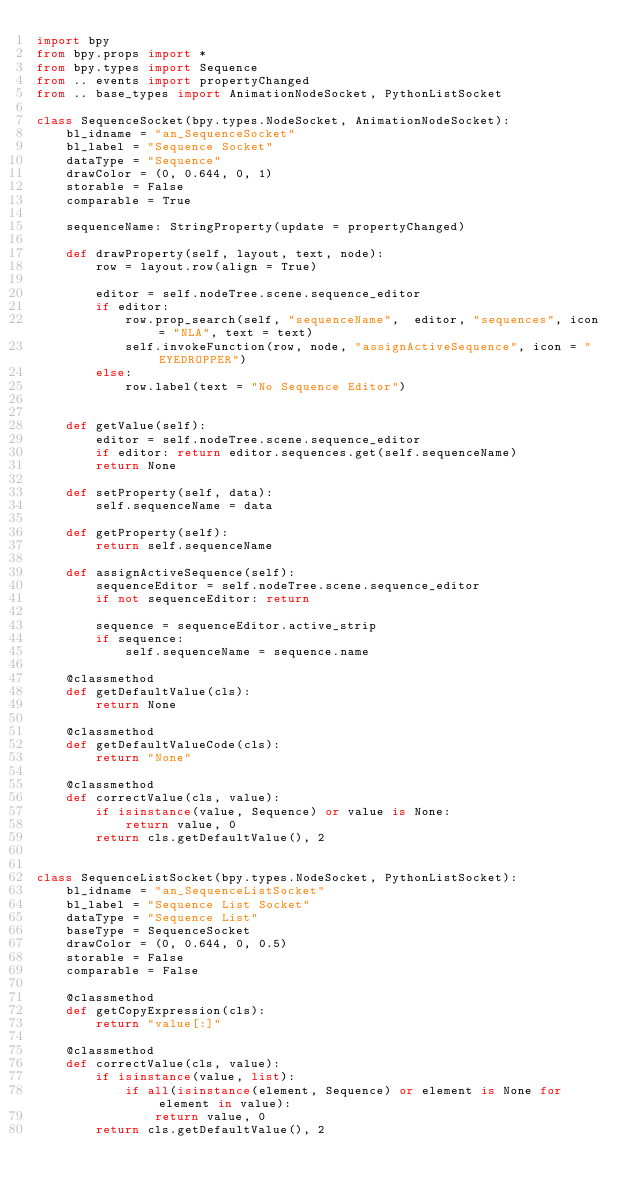<code> <loc_0><loc_0><loc_500><loc_500><_Python_>import bpy
from bpy.props import *
from bpy.types import Sequence
from .. events import propertyChanged
from .. base_types import AnimationNodeSocket, PythonListSocket

class SequenceSocket(bpy.types.NodeSocket, AnimationNodeSocket):
    bl_idname = "an_SequenceSocket"
    bl_label = "Sequence Socket"
    dataType = "Sequence"
    drawColor = (0, 0.644, 0, 1)
    storable = False
    comparable = True

    sequenceName: StringProperty(update = propertyChanged)

    def drawProperty(self, layout, text, node):
        row = layout.row(align = True)

        editor = self.nodeTree.scene.sequence_editor
        if editor:
            row.prop_search(self, "sequenceName",  editor, "sequences", icon = "NLA", text = text)
            self.invokeFunction(row, node, "assignActiveSequence", icon = "EYEDROPPER")
        else:
            row.label(text = "No Sequence Editor")


    def getValue(self):
        editor = self.nodeTree.scene.sequence_editor
        if editor: return editor.sequences.get(self.sequenceName)
        return None

    def setProperty(self, data):
        self.sequenceName = data

    def getProperty(self):
        return self.sequenceName

    def assignActiveSequence(self):
        sequenceEditor = self.nodeTree.scene.sequence_editor
        if not sequenceEditor: return

        sequence = sequenceEditor.active_strip
        if sequence:
            self.sequenceName = sequence.name

    @classmethod
    def getDefaultValue(cls):
        return None

    @classmethod
    def getDefaultValueCode(cls):
        return "None"

    @classmethod
    def correctValue(cls, value):
        if isinstance(value, Sequence) or value is None:
            return value, 0
        return cls.getDefaultValue(), 2


class SequenceListSocket(bpy.types.NodeSocket, PythonListSocket):
    bl_idname = "an_SequenceListSocket"
    bl_label = "Sequence List Socket"
    dataType = "Sequence List"
    baseType = SequenceSocket
    drawColor = (0, 0.644, 0, 0.5)
    storable = False
    comparable = False

    @classmethod
    def getCopyExpression(cls):
        return "value[:]"

    @classmethod
    def correctValue(cls, value):
        if isinstance(value, list):
            if all(isinstance(element, Sequence) or element is None for element in value):
                return value, 0
        return cls.getDefaultValue(), 2
</code> 